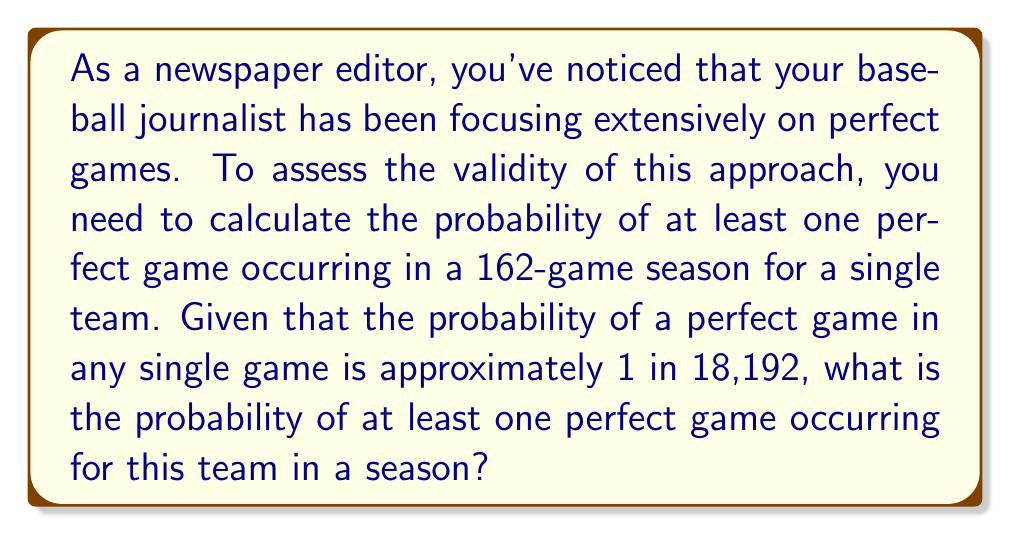Could you help me with this problem? Let's approach this step-by-step:

1) First, let's define our probability:
   $p = \frac{1}{18,192}$ (probability of a perfect game in a single game)

2) We want to find the probability of at least one perfect game in 162 games. It's easier to calculate the probability of no perfect games and then subtract from 1.

3) The probability of no perfect game in a single game is:
   $1 - p = 1 - \frac{1}{18,192} = \frac{18,191}{18,192}$

4) For no perfect games in 162 games, this probability must occur 162 times in a row. We can calculate this using exponentiation:

   $P(\text{no perfect games}) = (\frac{18,191}{18,192})^{162}$

5) Now, we can calculate the probability of at least one perfect game:

   $P(\text{at least one perfect game}) = 1 - P(\text{no perfect games})$

   $= 1 - (\frac{18,191}{18,192})^{162}$

6) Let's calculate this:

   $1 - (\frac{18,191}{18,192})^{162} \approx 0.008857$

7) Convert to a percentage:

   $0.008857 \times 100\% \approx 0.8857\%$
Answer: $\approx 0.89\%$ 